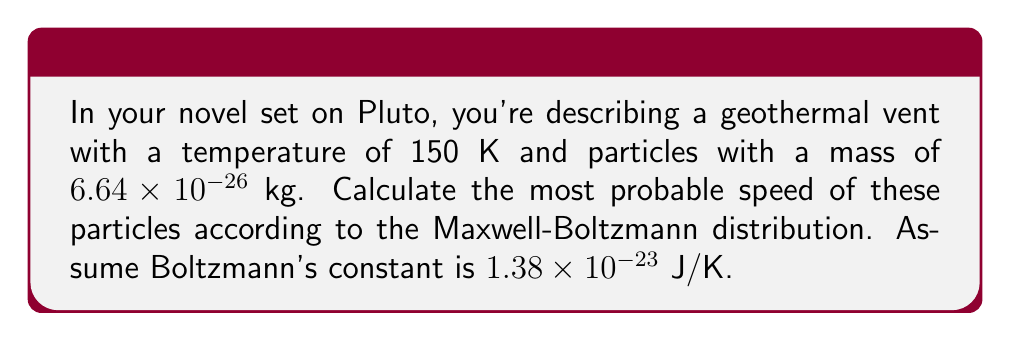Show me your answer to this math problem. To find the most probable speed in the Maxwell-Boltzmann distribution, we use the formula:

$$v_p = \sqrt{\frac{2k_BT}{m}}$$

Where:
$v_p$ = most probable speed
$k_B$ = Boltzmann's constant
$T$ = temperature
$m$ = mass of the particle

Step 1: Substitute the given values into the equation.
$k_B = 1.38 \times 10^{-23}$ J/K
$T = 150$ K
$m = 6.64 \times 10^{-26}$ kg

Step 2: Calculate the value under the square root.
$$\frac{2k_BT}{m} = \frac{2(1.38 \times 10^{-23})(150)}{6.64 \times 10^{-26}}$$

Step 3: Simplify the calculation.
$$\frac{2k_BT}{m} = \frac{4.14 \times 10^{-21}}{6.64 \times 10^{-26}} = 6.23 \times 10^4$$

Step 4: Take the square root to find $v_p$.
$$v_p = \sqrt{6.23 \times 10^4} = 249.6 \text{ m/s}$$

Step 5: Round to three significant figures.
$v_p \approx 250 \text{ m/s}$
Answer: 250 m/s 